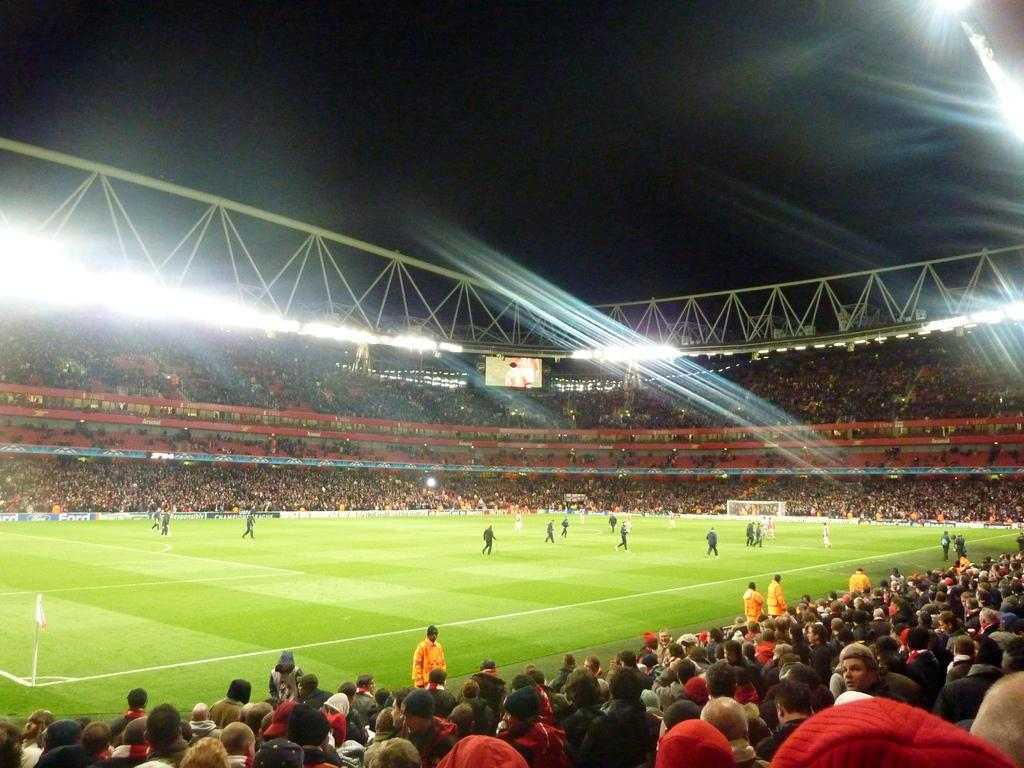Where is the image taken? The image is taken in a ground. What can be seen in the auditorium? There are many people sitting in an auditorium. What is located in the middle of the image? There are lights in the middle of the image. What is visible at the top of the image? The sky is visible at the top of the image. What type of fruit is being served in the oven in the image? There is no fruit or oven present in the image. 